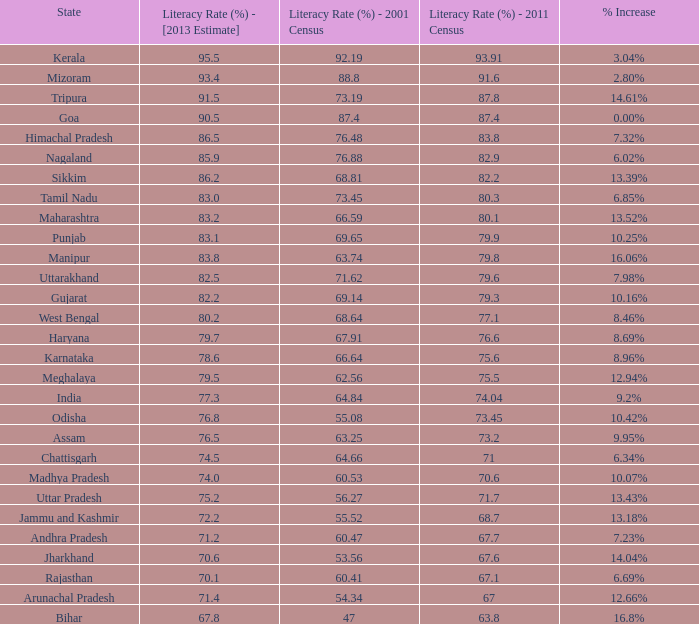What is the median increment in literacy for the states that had a rate exceeding 7 10.42%. 